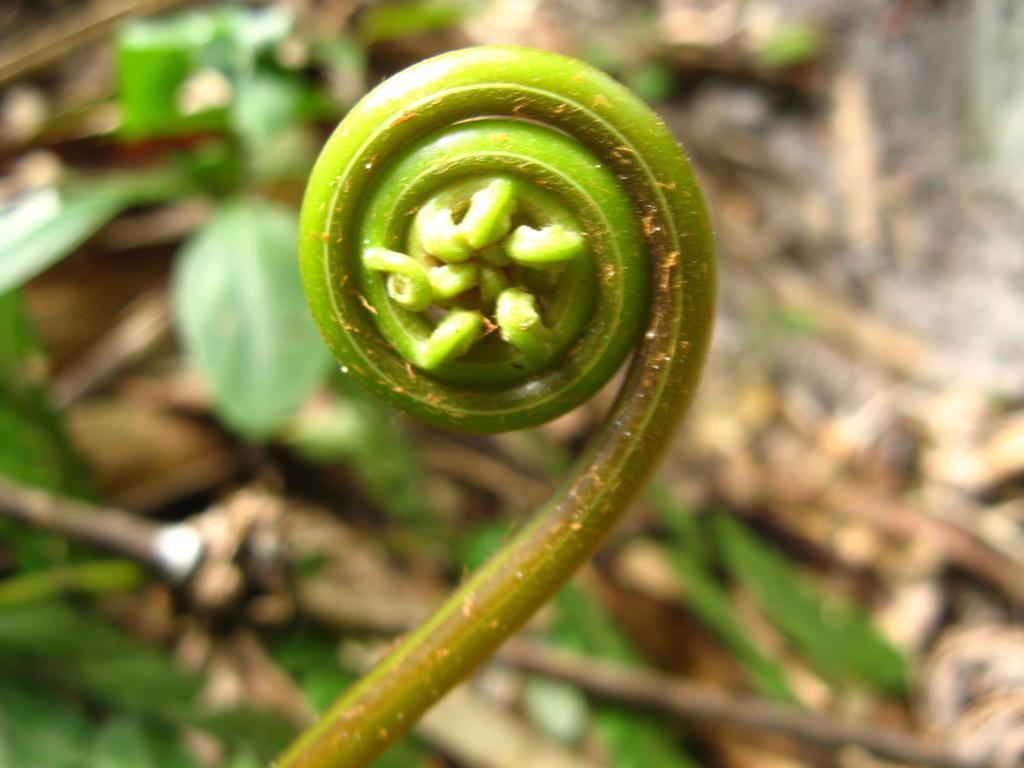Please provide a concise description of this image. In this picture we can see plant. In the background of the image it is blurry and we can see leaves. 